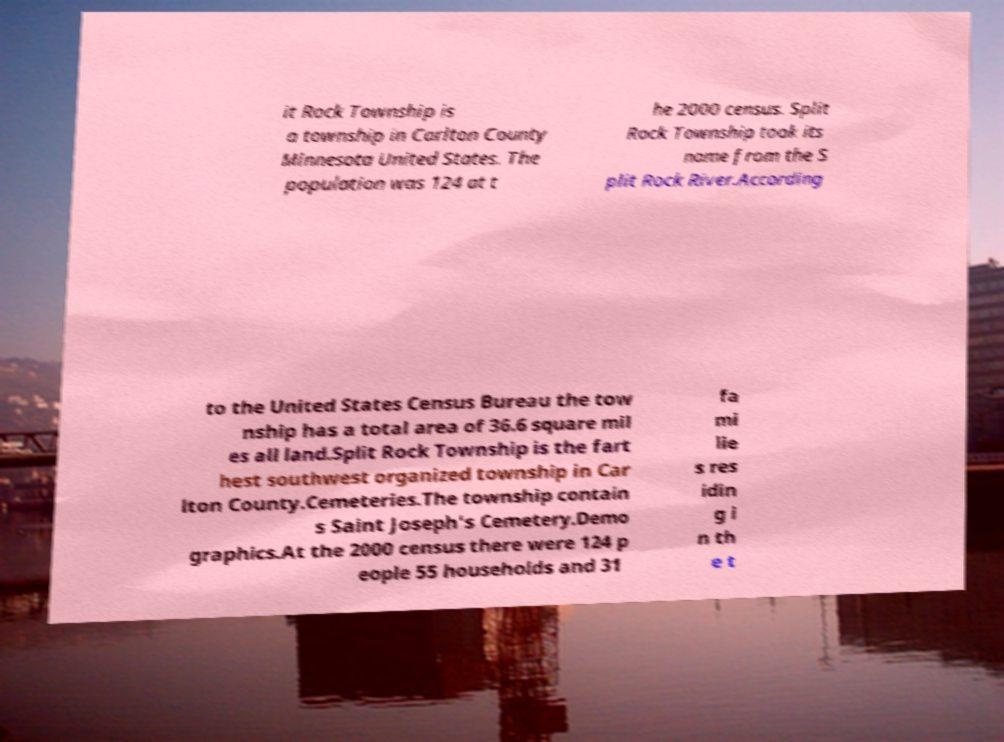Can you read and provide the text displayed in the image?This photo seems to have some interesting text. Can you extract and type it out for me? it Rock Township is a township in Carlton County Minnesota United States. The population was 124 at t he 2000 census. Split Rock Township took its name from the S plit Rock River.According to the United States Census Bureau the tow nship has a total area of 36.6 square mil es all land.Split Rock Township is the fart hest southwest organized township in Car lton County.Cemeteries.The township contain s Saint Joseph's Cemetery.Demo graphics.At the 2000 census there were 124 p eople 55 households and 31 fa mi lie s res idin g i n th e t 